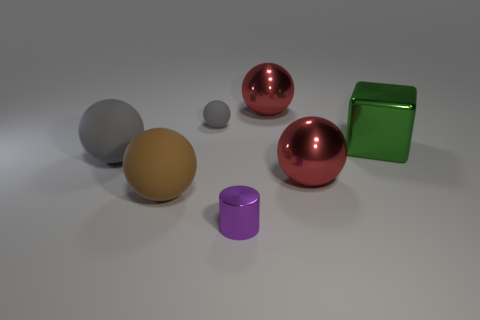Subtract all small matte spheres. How many spheres are left? 4 Subtract 1 spheres. How many spheres are left? 4 Subtract all green balls. Subtract all cyan cylinders. How many balls are left? 5 Add 1 large green objects. How many objects exist? 8 Subtract all cylinders. How many objects are left? 6 Add 4 small balls. How many small balls are left? 5 Add 3 large green metallic blocks. How many large green metallic blocks exist? 4 Subtract 0 blue cylinders. How many objects are left? 7 Subtract all brown matte things. Subtract all big objects. How many objects are left? 1 